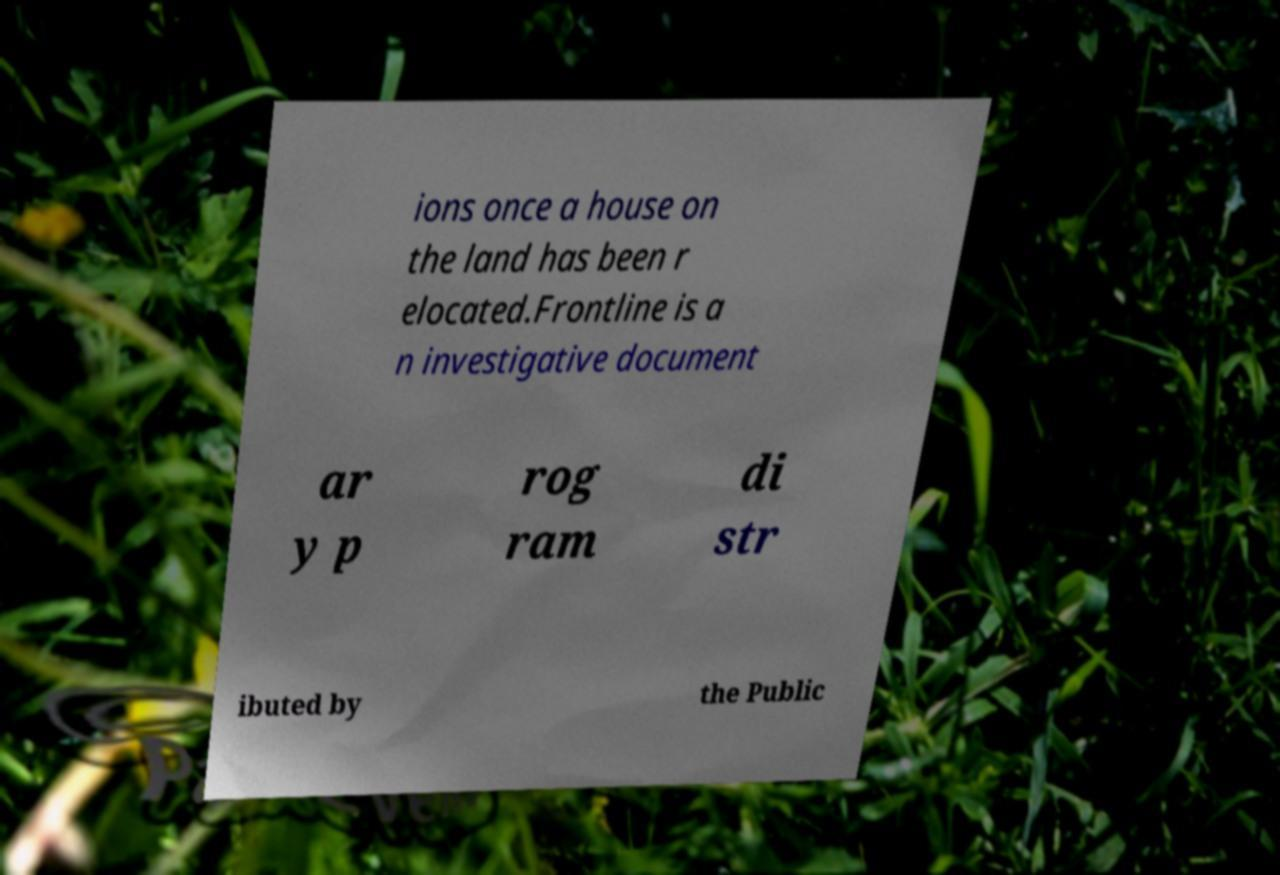Could you assist in decoding the text presented in this image and type it out clearly? ions once a house on the land has been r elocated.Frontline is a n investigative document ar y p rog ram di str ibuted by the Public 